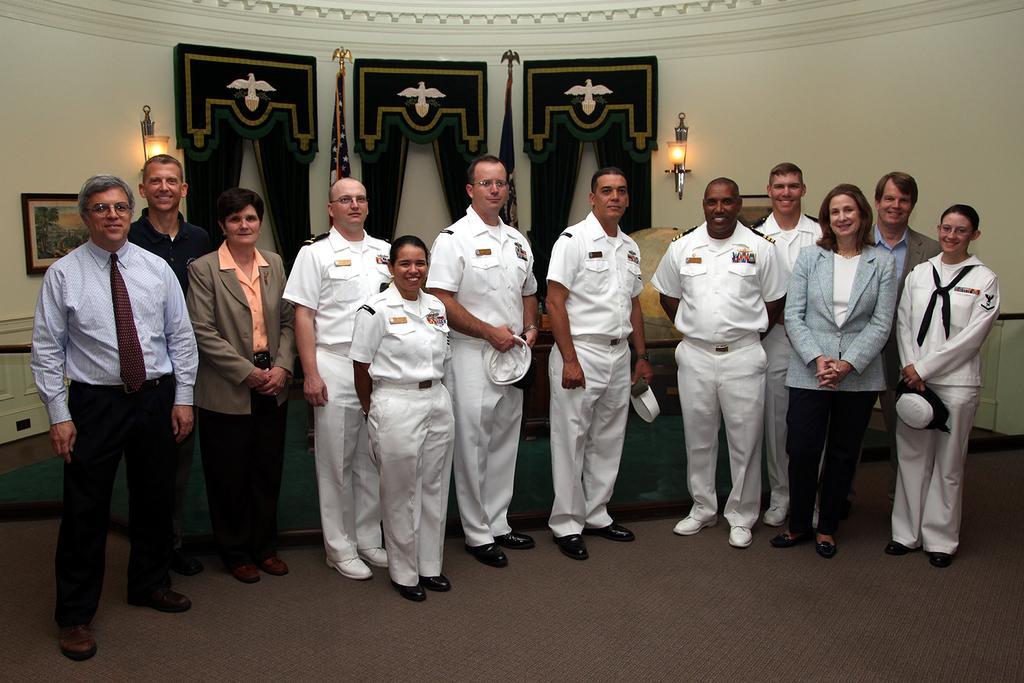Can you describe this image briefly? In the image,there is a navy army and few other people gathered for a photograph and behind them there is a wall and to the wall there are two lights and a photo frame are attached. 